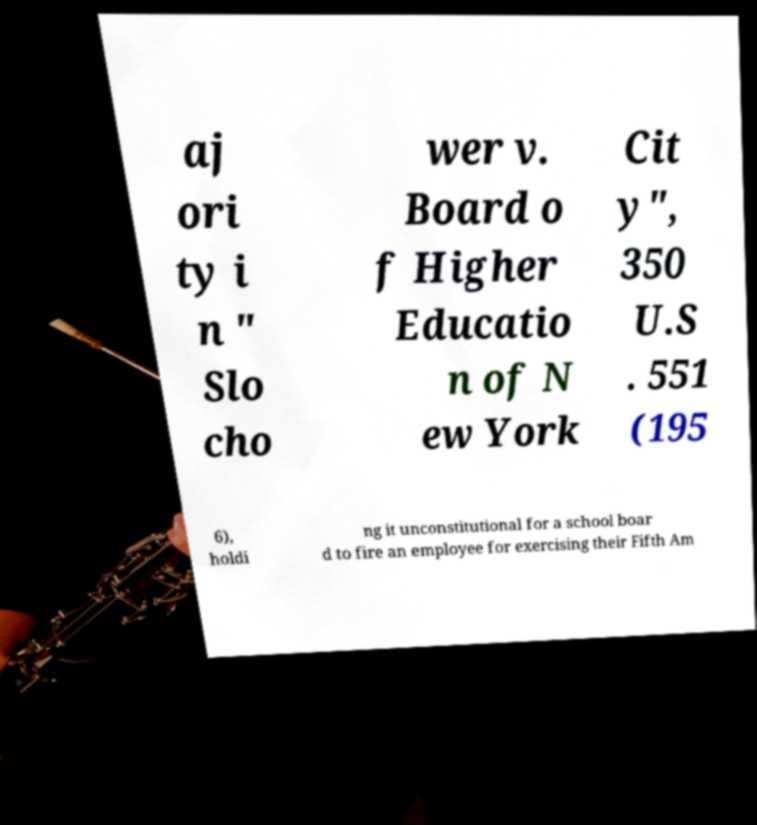I need the written content from this picture converted into text. Can you do that? aj ori ty i n " Slo cho wer v. Board o f Higher Educatio n of N ew York Cit y", 350 U.S . 551 (195 6), holdi ng it unconstitutional for a school boar d to fire an employee for exercising their Fifth Am 